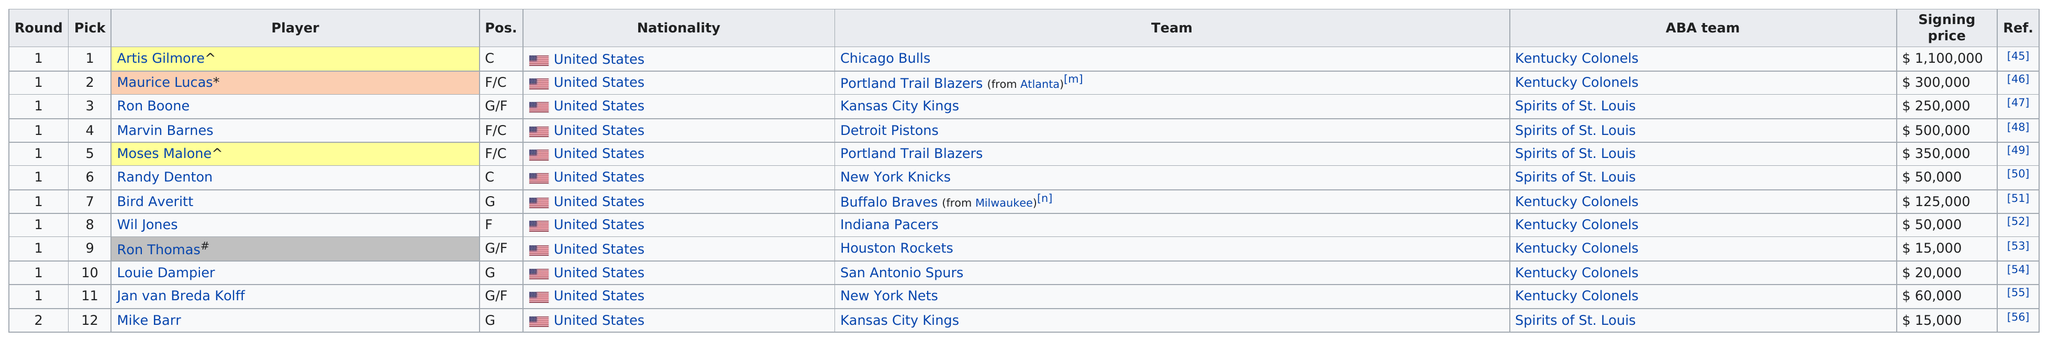Draw attention to some important aspects in this diagram. After Moses Malone, the pick was Randy Denton. Five centers were selected in the first round. The average signing price of all players was $236,250. 